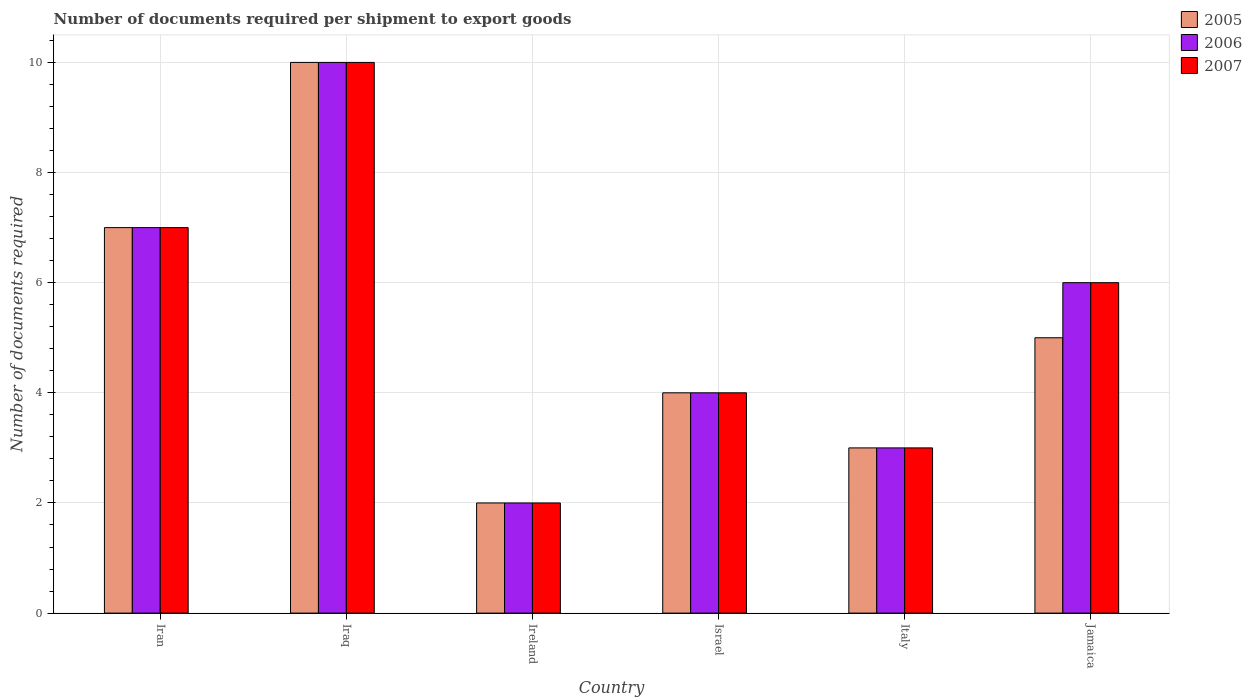How many different coloured bars are there?
Ensure brevity in your answer.  3. How many groups of bars are there?
Offer a terse response. 6. What is the label of the 2nd group of bars from the left?
Make the answer very short. Iraq. Across all countries, what is the minimum number of documents required per shipment to export goods in 2007?
Give a very brief answer. 2. In which country was the number of documents required per shipment to export goods in 2006 maximum?
Keep it short and to the point. Iraq. In which country was the number of documents required per shipment to export goods in 2005 minimum?
Your answer should be very brief. Ireland. What is the difference between the number of documents required per shipment to export goods in 2007 in Jamaica and the number of documents required per shipment to export goods in 2005 in Ireland?
Your answer should be compact. 4. What is the average number of documents required per shipment to export goods in 2007 per country?
Your response must be concise. 5.33. What is the difference between the number of documents required per shipment to export goods of/in 2006 and number of documents required per shipment to export goods of/in 2007 in Iraq?
Provide a succinct answer. 0. In how many countries, is the number of documents required per shipment to export goods in 2007 greater than 0.4?
Offer a very short reply. 6. Is the number of documents required per shipment to export goods in 2005 in Iran less than that in Jamaica?
Make the answer very short. No. What is the difference between the highest and the second highest number of documents required per shipment to export goods in 2005?
Your answer should be very brief. 5. What does the 2nd bar from the right in Iraq represents?
Offer a very short reply. 2006. Is it the case that in every country, the sum of the number of documents required per shipment to export goods in 2007 and number of documents required per shipment to export goods in 2006 is greater than the number of documents required per shipment to export goods in 2005?
Give a very brief answer. Yes. Are the values on the major ticks of Y-axis written in scientific E-notation?
Offer a terse response. No. Where does the legend appear in the graph?
Offer a terse response. Top right. How many legend labels are there?
Make the answer very short. 3. What is the title of the graph?
Offer a terse response. Number of documents required per shipment to export goods. Does "2004" appear as one of the legend labels in the graph?
Make the answer very short. No. What is the label or title of the X-axis?
Keep it short and to the point. Country. What is the label or title of the Y-axis?
Make the answer very short. Number of documents required. What is the Number of documents required in 2005 in Iran?
Your answer should be very brief. 7. What is the Number of documents required of 2007 in Iran?
Ensure brevity in your answer.  7. What is the Number of documents required of 2006 in Iraq?
Make the answer very short. 10. What is the Number of documents required of 2005 in Ireland?
Make the answer very short. 2. What is the Number of documents required of 2006 in Ireland?
Give a very brief answer. 2. What is the Number of documents required in 2005 in Israel?
Your response must be concise. 4. What is the Number of documents required of 2006 in Israel?
Your response must be concise. 4. What is the Number of documents required of 2007 in Israel?
Offer a terse response. 4. What is the Number of documents required of 2006 in Jamaica?
Offer a very short reply. 6. Across all countries, what is the minimum Number of documents required of 2005?
Provide a short and direct response. 2. Across all countries, what is the minimum Number of documents required of 2006?
Your response must be concise. 2. Across all countries, what is the minimum Number of documents required of 2007?
Your response must be concise. 2. What is the total Number of documents required of 2005 in the graph?
Your response must be concise. 31. What is the total Number of documents required in 2006 in the graph?
Offer a terse response. 32. What is the total Number of documents required in 2007 in the graph?
Give a very brief answer. 32. What is the difference between the Number of documents required of 2005 in Iran and that in Iraq?
Keep it short and to the point. -3. What is the difference between the Number of documents required of 2005 in Iran and that in Israel?
Give a very brief answer. 3. What is the difference between the Number of documents required of 2007 in Iran and that in Israel?
Give a very brief answer. 3. What is the difference between the Number of documents required of 2005 in Iran and that in Italy?
Provide a short and direct response. 4. What is the difference between the Number of documents required of 2006 in Iran and that in Italy?
Make the answer very short. 4. What is the difference between the Number of documents required in 2007 in Iran and that in Italy?
Offer a very short reply. 4. What is the difference between the Number of documents required in 2006 in Iran and that in Jamaica?
Your answer should be compact. 1. What is the difference between the Number of documents required in 2007 in Iran and that in Jamaica?
Ensure brevity in your answer.  1. What is the difference between the Number of documents required in 2006 in Iraq and that in Ireland?
Ensure brevity in your answer.  8. What is the difference between the Number of documents required of 2007 in Iraq and that in Ireland?
Ensure brevity in your answer.  8. What is the difference between the Number of documents required of 2005 in Iraq and that in Israel?
Provide a short and direct response. 6. What is the difference between the Number of documents required of 2006 in Iraq and that in Israel?
Make the answer very short. 6. What is the difference between the Number of documents required in 2007 in Iraq and that in Israel?
Your answer should be very brief. 6. What is the difference between the Number of documents required in 2005 in Iraq and that in Italy?
Offer a very short reply. 7. What is the difference between the Number of documents required of 2005 in Ireland and that in Israel?
Your answer should be very brief. -2. What is the difference between the Number of documents required of 2005 in Ireland and that in Italy?
Keep it short and to the point. -1. What is the difference between the Number of documents required of 2006 in Ireland and that in Jamaica?
Provide a succinct answer. -4. What is the difference between the Number of documents required in 2007 in Ireland and that in Jamaica?
Provide a short and direct response. -4. What is the difference between the Number of documents required in 2006 in Israel and that in Italy?
Provide a succinct answer. 1. What is the difference between the Number of documents required in 2005 in Israel and that in Jamaica?
Ensure brevity in your answer.  -1. What is the difference between the Number of documents required of 2005 in Italy and that in Jamaica?
Ensure brevity in your answer.  -2. What is the difference between the Number of documents required of 2006 in Italy and that in Jamaica?
Keep it short and to the point. -3. What is the difference between the Number of documents required in 2006 in Iran and the Number of documents required in 2007 in Iraq?
Ensure brevity in your answer.  -3. What is the difference between the Number of documents required of 2005 in Iran and the Number of documents required of 2006 in Ireland?
Offer a terse response. 5. What is the difference between the Number of documents required of 2005 in Iran and the Number of documents required of 2007 in Italy?
Ensure brevity in your answer.  4. What is the difference between the Number of documents required in 2006 in Iran and the Number of documents required in 2007 in Italy?
Your answer should be very brief. 4. What is the difference between the Number of documents required in 2005 in Iran and the Number of documents required in 2006 in Jamaica?
Your answer should be very brief. 1. What is the difference between the Number of documents required in 2005 in Iran and the Number of documents required in 2007 in Jamaica?
Make the answer very short. 1. What is the difference between the Number of documents required in 2006 in Iran and the Number of documents required in 2007 in Jamaica?
Offer a very short reply. 1. What is the difference between the Number of documents required in 2005 in Iraq and the Number of documents required in 2006 in Ireland?
Provide a succinct answer. 8. What is the difference between the Number of documents required in 2005 in Iraq and the Number of documents required in 2007 in Israel?
Keep it short and to the point. 6. What is the difference between the Number of documents required in 2006 in Iraq and the Number of documents required in 2007 in Israel?
Provide a succinct answer. 6. What is the difference between the Number of documents required in 2005 in Iraq and the Number of documents required in 2006 in Italy?
Offer a very short reply. 7. What is the difference between the Number of documents required in 2005 in Iraq and the Number of documents required in 2007 in Italy?
Keep it short and to the point. 7. What is the difference between the Number of documents required in 2006 in Iraq and the Number of documents required in 2007 in Jamaica?
Provide a short and direct response. 4. What is the difference between the Number of documents required of 2005 in Ireland and the Number of documents required of 2006 in Israel?
Your response must be concise. -2. What is the difference between the Number of documents required of 2006 in Ireland and the Number of documents required of 2007 in Israel?
Provide a succinct answer. -2. What is the difference between the Number of documents required of 2005 in Ireland and the Number of documents required of 2007 in Italy?
Provide a short and direct response. -1. What is the difference between the Number of documents required in 2005 in Ireland and the Number of documents required in 2006 in Jamaica?
Offer a very short reply. -4. What is the difference between the Number of documents required in 2005 in Ireland and the Number of documents required in 2007 in Jamaica?
Your answer should be compact. -4. What is the difference between the Number of documents required in 2006 in Israel and the Number of documents required in 2007 in Italy?
Ensure brevity in your answer.  1. What is the difference between the Number of documents required in 2005 in Israel and the Number of documents required in 2006 in Jamaica?
Keep it short and to the point. -2. What is the difference between the Number of documents required in 2005 in Israel and the Number of documents required in 2007 in Jamaica?
Provide a succinct answer. -2. What is the difference between the Number of documents required in 2006 in Italy and the Number of documents required in 2007 in Jamaica?
Ensure brevity in your answer.  -3. What is the average Number of documents required in 2005 per country?
Make the answer very short. 5.17. What is the average Number of documents required of 2006 per country?
Offer a terse response. 5.33. What is the average Number of documents required in 2007 per country?
Your answer should be compact. 5.33. What is the difference between the Number of documents required in 2005 and Number of documents required in 2006 in Iran?
Offer a very short reply. 0. What is the difference between the Number of documents required of 2005 and Number of documents required of 2007 in Iran?
Provide a short and direct response. 0. What is the difference between the Number of documents required of 2006 and Number of documents required of 2007 in Iran?
Your answer should be compact. 0. What is the difference between the Number of documents required in 2005 and Number of documents required in 2007 in Iraq?
Provide a short and direct response. 0. What is the difference between the Number of documents required in 2005 and Number of documents required in 2007 in Ireland?
Ensure brevity in your answer.  0. What is the difference between the Number of documents required in 2005 and Number of documents required in 2006 in Israel?
Give a very brief answer. 0. What is the difference between the Number of documents required of 2005 and Number of documents required of 2007 in Israel?
Your response must be concise. 0. What is the ratio of the Number of documents required of 2005 in Iran to that in Iraq?
Make the answer very short. 0.7. What is the ratio of the Number of documents required in 2006 in Iran to that in Iraq?
Make the answer very short. 0.7. What is the ratio of the Number of documents required of 2007 in Iran to that in Iraq?
Offer a terse response. 0.7. What is the ratio of the Number of documents required of 2005 in Iran to that in Italy?
Your answer should be compact. 2.33. What is the ratio of the Number of documents required of 2006 in Iran to that in Italy?
Provide a short and direct response. 2.33. What is the ratio of the Number of documents required in 2007 in Iran to that in Italy?
Your answer should be very brief. 2.33. What is the ratio of the Number of documents required of 2007 in Iran to that in Jamaica?
Offer a very short reply. 1.17. What is the ratio of the Number of documents required of 2006 in Iraq to that in Ireland?
Offer a terse response. 5. What is the ratio of the Number of documents required of 2005 in Iraq to that in Israel?
Your response must be concise. 2.5. What is the ratio of the Number of documents required of 2006 in Iraq to that in Israel?
Make the answer very short. 2.5. What is the ratio of the Number of documents required in 2007 in Iraq to that in Israel?
Keep it short and to the point. 2.5. What is the ratio of the Number of documents required in 2006 in Iraq to that in Italy?
Your response must be concise. 3.33. What is the ratio of the Number of documents required of 2007 in Iraq to that in Italy?
Ensure brevity in your answer.  3.33. What is the ratio of the Number of documents required in 2005 in Iraq to that in Jamaica?
Your response must be concise. 2. What is the ratio of the Number of documents required of 2005 in Ireland to that in Israel?
Your answer should be compact. 0.5. What is the ratio of the Number of documents required in 2006 in Ireland to that in Israel?
Provide a succinct answer. 0.5. What is the ratio of the Number of documents required in 2007 in Ireland to that in Israel?
Provide a succinct answer. 0.5. What is the ratio of the Number of documents required of 2005 in Ireland to that in Italy?
Give a very brief answer. 0.67. What is the ratio of the Number of documents required of 2007 in Ireland to that in Italy?
Make the answer very short. 0.67. What is the ratio of the Number of documents required of 2007 in Ireland to that in Jamaica?
Make the answer very short. 0.33. What is the ratio of the Number of documents required of 2007 in Israel to that in Italy?
Offer a very short reply. 1.33. What is the ratio of the Number of documents required of 2005 in Israel to that in Jamaica?
Keep it short and to the point. 0.8. What is the ratio of the Number of documents required in 2006 in Israel to that in Jamaica?
Provide a succinct answer. 0.67. What is the ratio of the Number of documents required of 2007 in Israel to that in Jamaica?
Offer a terse response. 0.67. What is the ratio of the Number of documents required in 2006 in Italy to that in Jamaica?
Your answer should be compact. 0.5. What is the ratio of the Number of documents required of 2007 in Italy to that in Jamaica?
Your response must be concise. 0.5. What is the difference between the highest and the second highest Number of documents required in 2005?
Ensure brevity in your answer.  3. What is the difference between the highest and the second highest Number of documents required of 2007?
Keep it short and to the point. 3. What is the difference between the highest and the lowest Number of documents required in 2005?
Give a very brief answer. 8. What is the difference between the highest and the lowest Number of documents required in 2007?
Your response must be concise. 8. 